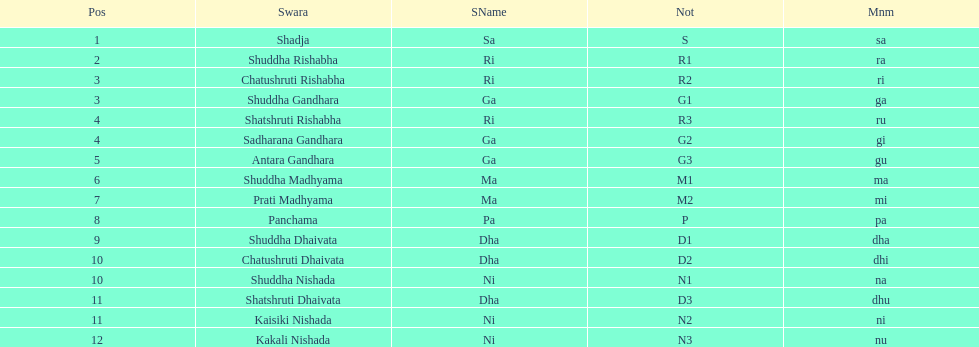Find the 9th position swara. what is its short name? Dha. 